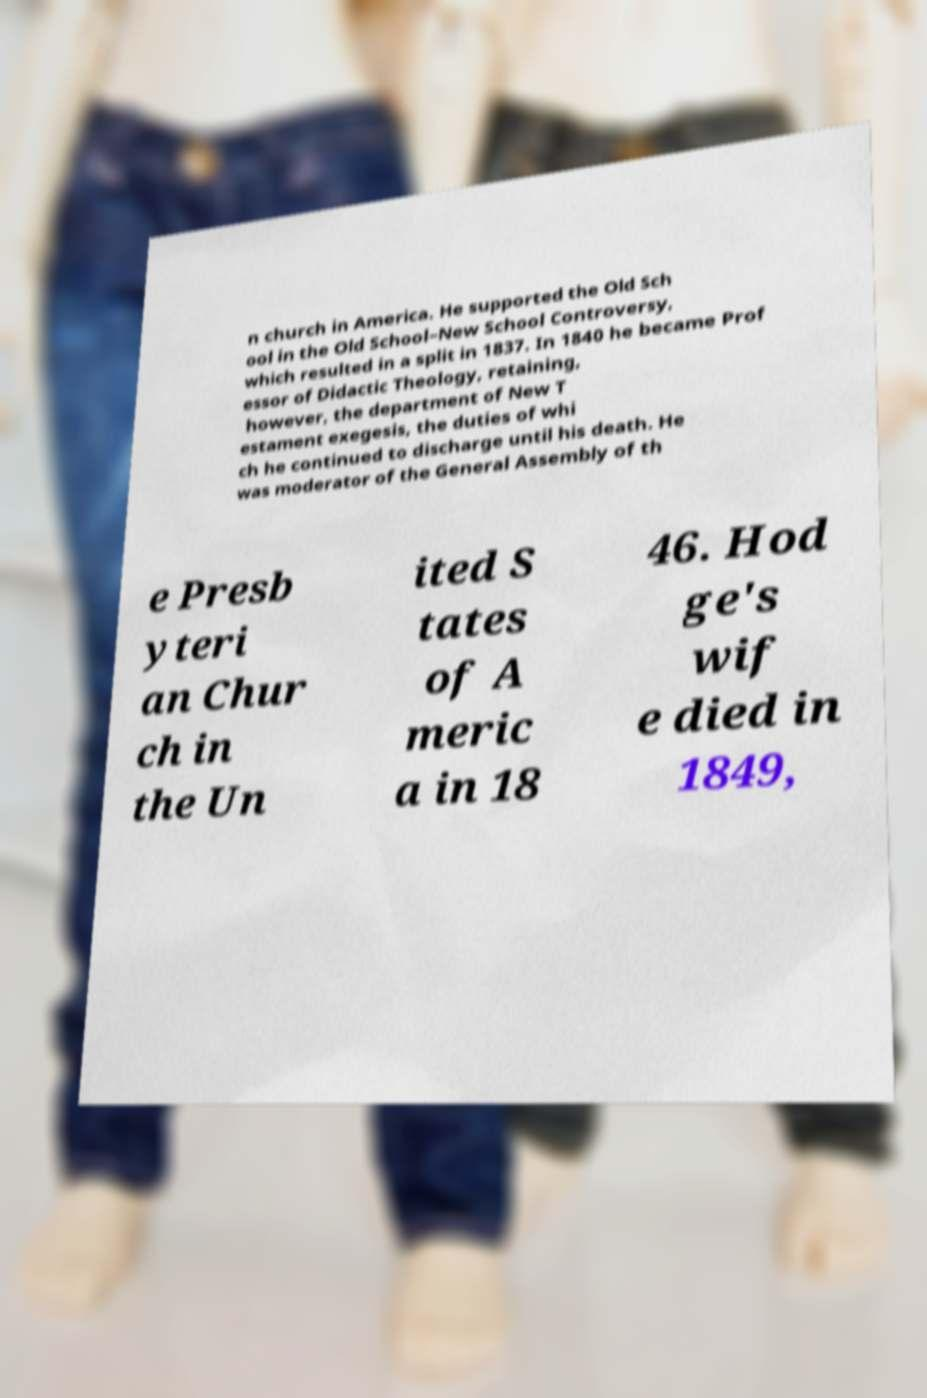I need the written content from this picture converted into text. Can you do that? n church in America. He supported the Old Sch ool in the Old School–New School Controversy, which resulted in a split in 1837. In 1840 he became Prof essor of Didactic Theology, retaining, however, the department of New T estament exegesis, the duties of whi ch he continued to discharge until his death. He was moderator of the General Assembly of th e Presb yteri an Chur ch in the Un ited S tates of A meric a in 18 46. Hod ge's wif e died in 1849, 